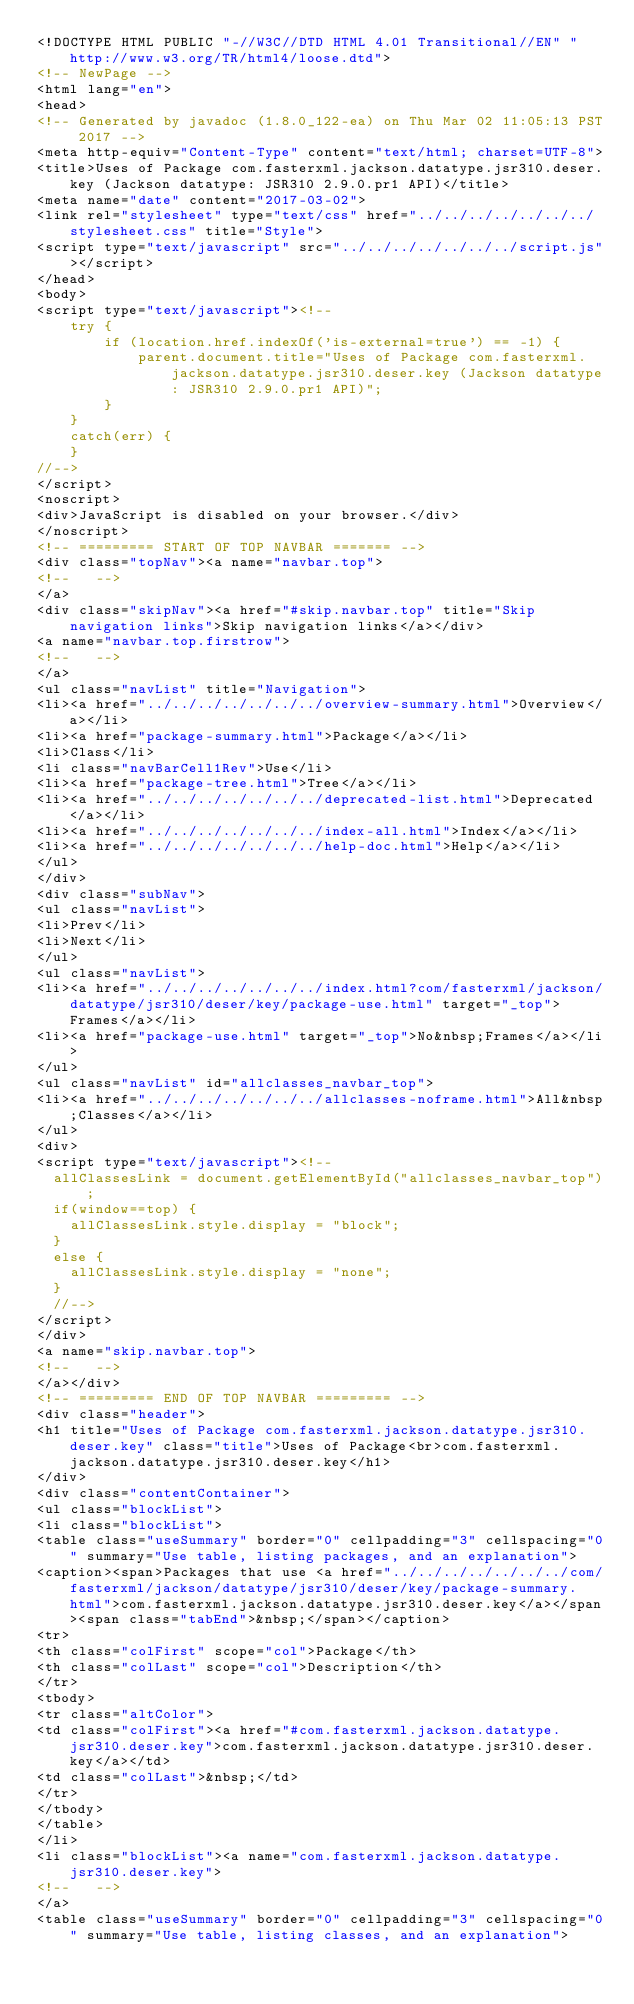<code> <loc_0><loc_0><loc_500><loc_500><_HTML_><!DOCTYPE HTML PUBLIC "-//W3C//DTD HTML 4.01 Transitional//EN" "http://www.w3.org/TR/html4/loose.dtd">
<!-- NewPage -->
<html lang="en">
<head>
<!-- Generated by javadoc (1.8.0_122-ea) on Thu Mar 02 11:05:13 PST 2017 -->
<meta http-equiv="Content-Type" content="text/html; charset=UTF-8">
<title>Uses of Package com.fasterxml.jackson.datatype.jsr310.deser.key (Jackson datatype: JSR310 2.9.0.pr1 API)</title>
<meta name="date" content="2017-03-02">
<link rel="stylesheet" type="text/css" href="../../../../../../../stylesheet.css" title="Style">
<script type="text/javascript" src="../../../../../../../script.js"></script>
</head>
<body>
<script type="text/javascript"><!--
    try {
        if (location.href.indexOf('is-external=true') == -1) {
            parent.document.title="Uses of Package com.fasterxml.jackson.datatype.jsr310.deser.key (Jackson datatype: JSR310 2.9.0.pr1 API)";
        }
    }
    catch(err) {
    }
//-->
</script>
<noscript>
<div>JavaScript is disabled on your browser.</div>
</noscript>
<!-- ========= START OF TOP NAVBAR ======= -->
<div class="topNav"><a name="navbar.top">
<!--   -->
</a>
<div class="skipNav"><a href="#skip.navbar.top" title="Skip navigation links">Skip navigation links</a></div>
<a name="navbar.top.firstrow">
<!--   -->
</a>
<ul class="navList" title="Navigation">
<li><a href="../../../../../../../overview-summary.html">Overview</a></li>
<li><a href="package-summary.html">Package</a></li>
<li>Class</li>
<li class="navBarCell1Rev">Use</li>
<li><a href="package-tree.html">Tree</a></li>
<li><a href="../../../../../../../deprecated-list.html">Deprecated</a></li>
<li><a href="../../../../../../../index-all.html">Index</a></li>
<li><a href="../../../../../../../help-doc.html">Help</a></li>
</ul>
</div>
<div class="subNav">
<ul class="navList">
<li>Prev</li>
<li>Next</li>
</ul>
<ul class="navList">
<li><a href="../../../../../../../index.html?com/fasterxml/jackson/datatype/jsr310/deser/key/package-use.html" target="_top">Frames</a></li>
<li><a href="package-use.html" target="_top">No&nbsp;Frames</a></li>
</ul>
<ul class="navList" id="allclasses_navbar_top">
<li><a href="../../../../../../../allclasses-noframe.html">All&nbsp;Classes</a></li>
</ul>
<div>
<script type="text/javascript"><!--
  allClassesLink = document.getElementById("allclasses_navbar_top");
  if(window==top) {
    allClassesLink.style.display = "block";
  }
  else {
    allClassesLink.style.display = "none";
  }
  //-->
</script>
</div>
<a name="skip.navbar.top">
<!--   -->
</a></div>
<!-- ========= END OF TOP NAVBAR ========= -->
<div class="header">
<h1 title="Uses of Package com.fasterxml.jackson.datatype.jsr310.deser.key" class="title">Uses of Package<br>com.fasterxml.jackson.datatype.jsr310.deser.key</h1>
</div>
<div class="contentContainer">
<ul class="blockList">
<li class="blockList">
<table class="useSummary" border="0" cellpadding="3" cellspacing="0" summary="Use table, listing packages, and an explanation">
<caption><span>Packages that use <a href="../../../../../../../com/fasterxml/jackson/datatype/jsr310/deser/key/package-summary.html">com.fasterxml.jackson.datatype.jsr310.deser.key</a></span><span class="tabEnd">&nbsp;</span></caption>
<tr>
<th class="colFirst" scope="col">Package</th>
<th class="colLast" scope="col">Description</th>
</tr>
<tbody>
<tr class="altColor">
<td class="colFirst"><a href="#com.fasterxml.jackson.datatype.jsr310.deser.key">com.fasterxml.jackson.datatype.jsr310.deser.key</a></td>
<td class="colLast">&nbsp;</td>
</tr>
</tbody>
</table>
</li>
<li class="blockList"><a name="com.fasterxml.jackson.datatype.jsr310.deser.key">
<!--   -->
</a>
<table class="useSummary" border="0" cellpadding="3" cellspacing="0" summary="Use table, listing classes, and an explanation"></code> 